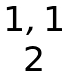<formula> <loc_0><loc_0><loc_500><loc_500>\begin{matrix} 1 , 1 \\ 2 \end{matrix}</formula> 